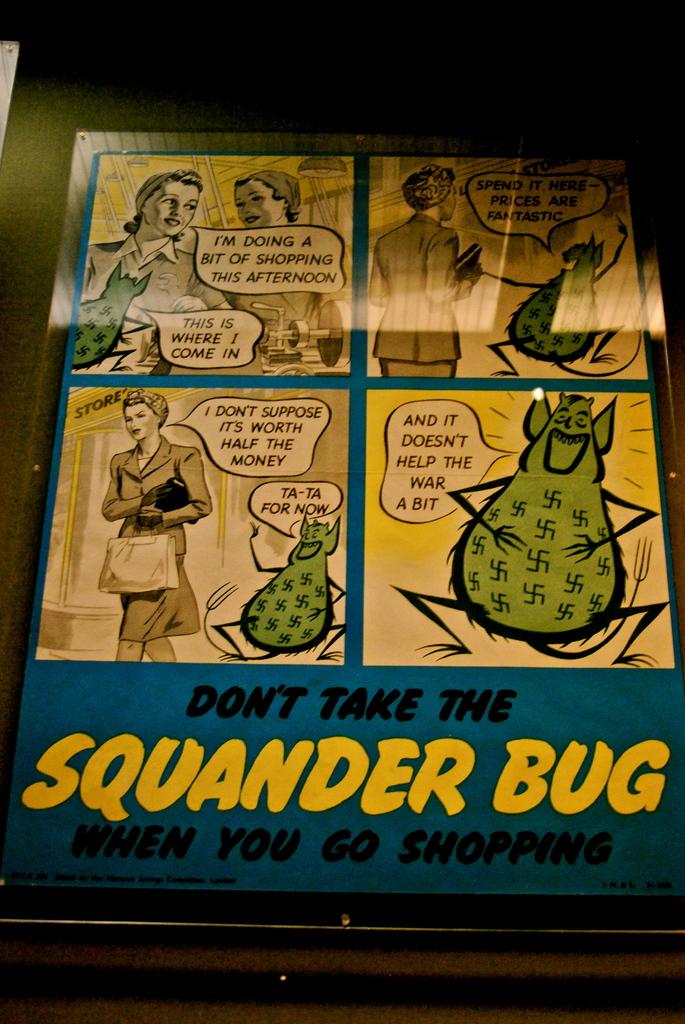What color is the word "squander"?
Make the answer very short. Yellow. 